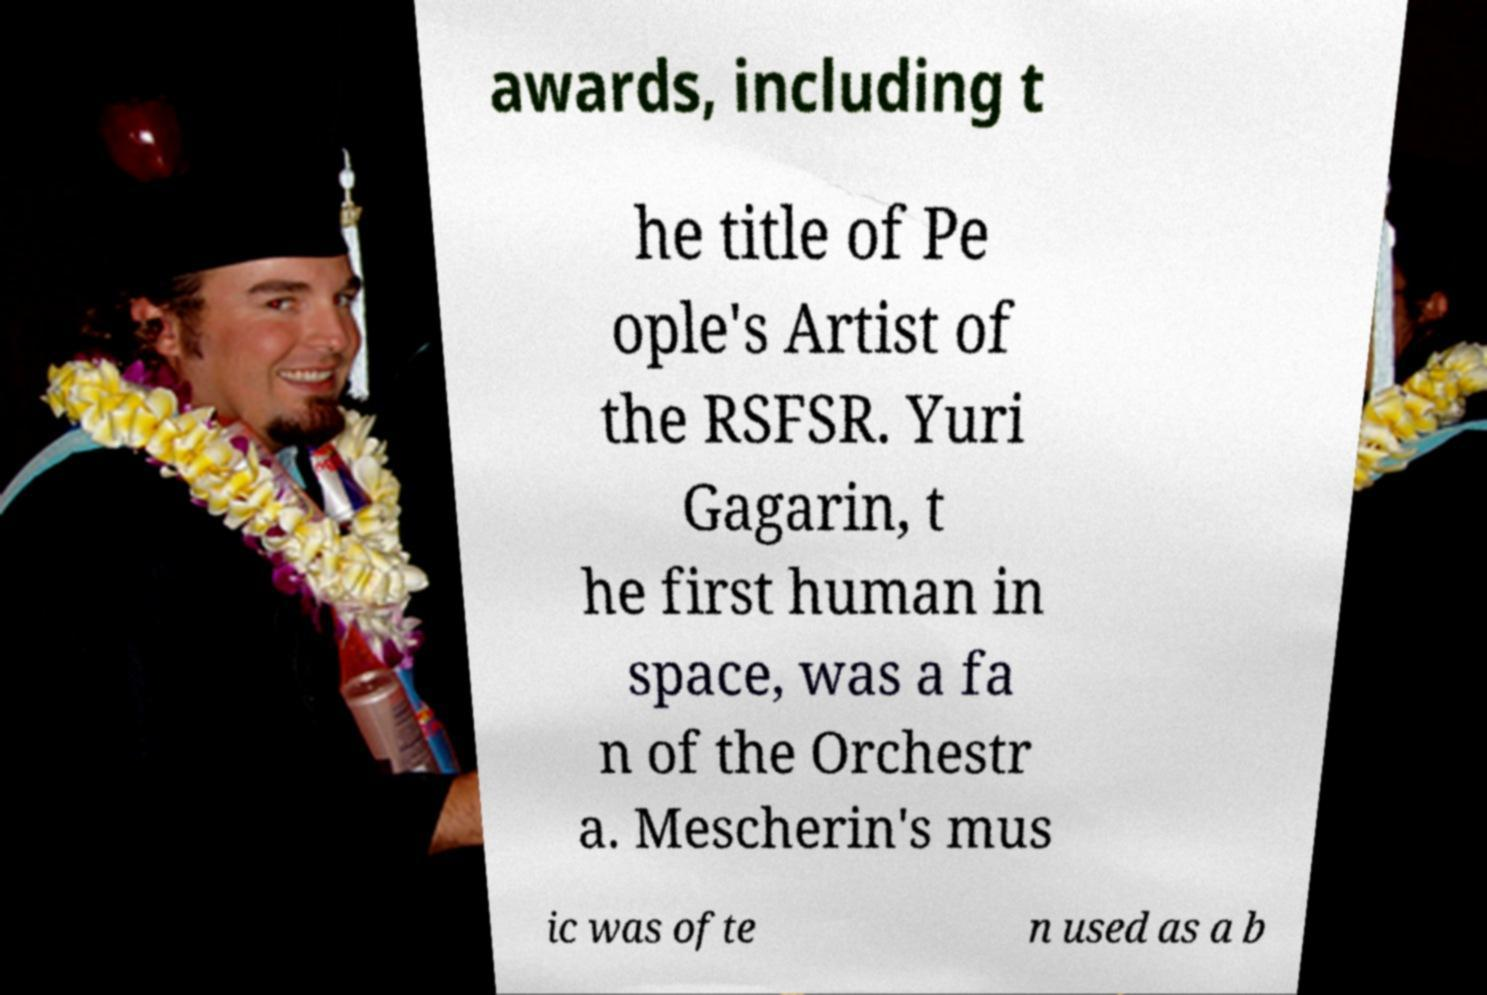Could you assist in decoding the text presented in this image and type it out clearly? awards, including t he title of Pe ople's Artist of the RSFSR. Yuri Gagarin, t he first human in space, was a fa n of the Orchestr a. Mescherin's mus ic was ofte n used as a b 